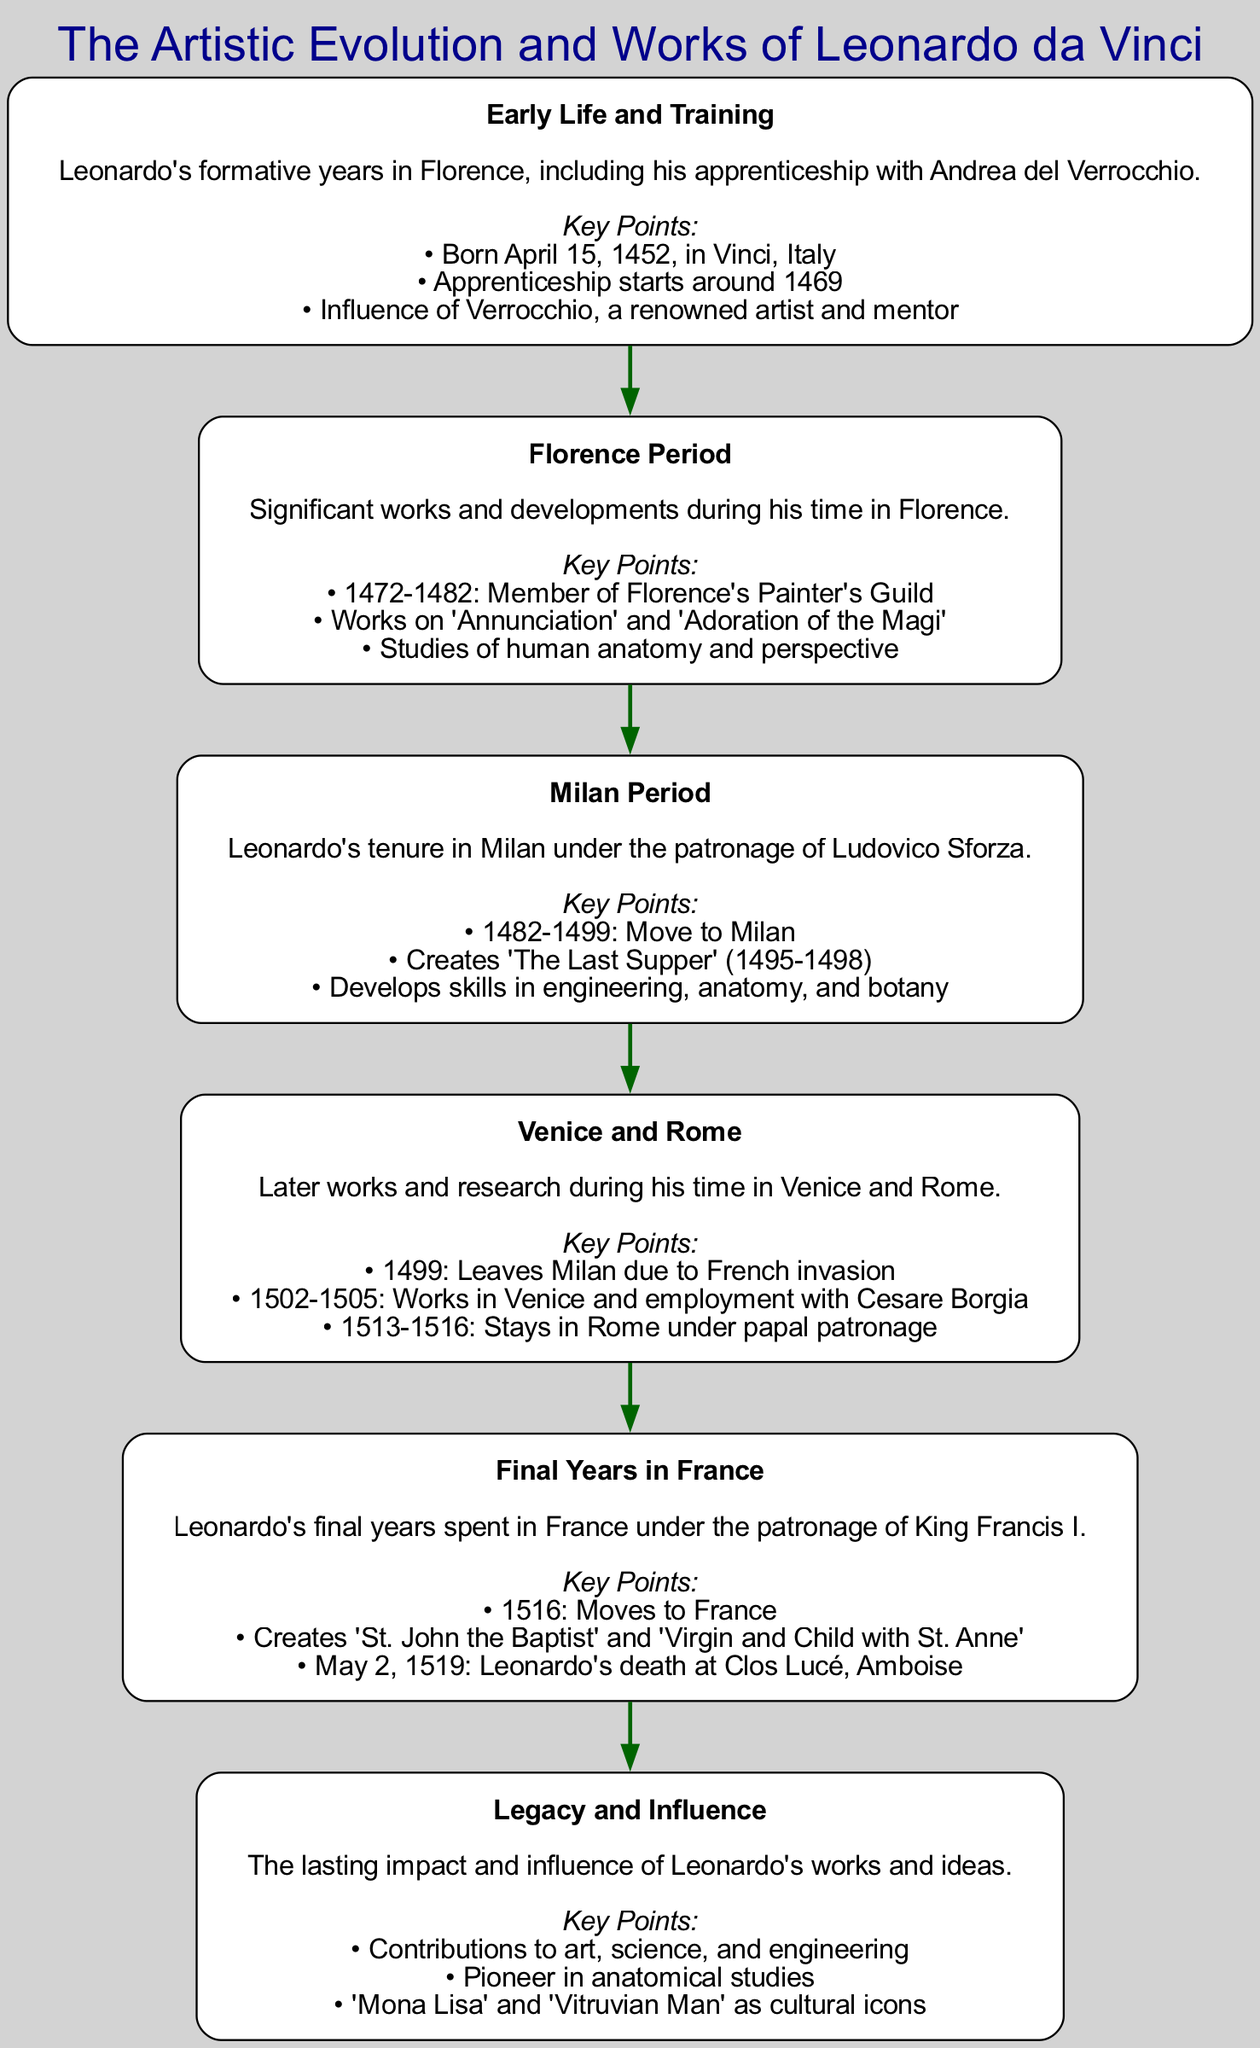What is the first block in the diagram? The first block in the diagram is titled "Early Life and Training," which is confirmed by looking at the topmost node of the block diagram.
Answer: Early Life and Training How many blocks are there in total? There are six blocks in the diagram, which can be counted by observing the number of distinct nodes presented.
Answer: 6 What significant work was created during the Milan period? The significant work created during the Milan period is "The Last Supper," as indicated in the key points under the "Milan Period" block.
Answer: The Last Supper Which block follows the "Florence Period" block? The block that follows the "Florence Period" block is the "Milan Period," since the edges connecting the blocks indicate the flow from one to the next.
Answer: Milan Period What year did Leonardo move to France? Leonardo moved to France in the year 1516, as mentioned in the key points of the "Final Years in France" block.
Answer: 1516 How did Leonardo's studies influence his later works? Leonardo's studies in human anatomy and perspective during his "Florence Period" provided foundational knowledge that informed his later masterpieces, evidenced by the connections between the blocks referring to his artistic evolution.
Answer: Influence of studies In which year was Leonardo's death? Leonardo's death occurred on May 2, 1519, which is stated as a key point in the "Final Years in France" block.
Answer: May 2, 1519 Which work is referenced as a cultural icon in the legacy and influence block? The work referenced as a cultural icon in the "Legacy and Influence" block is the "Mona Lisa," as listed among the contributions in the key points.
Answer: Mona Lisa What was a significant development during the "Florence Period"? A significant development during the "Florence Period" was the studies of human anatomy and perspective, which are highlighted in the key points of that block.
Answer: Studies of human anatomy and perspective 